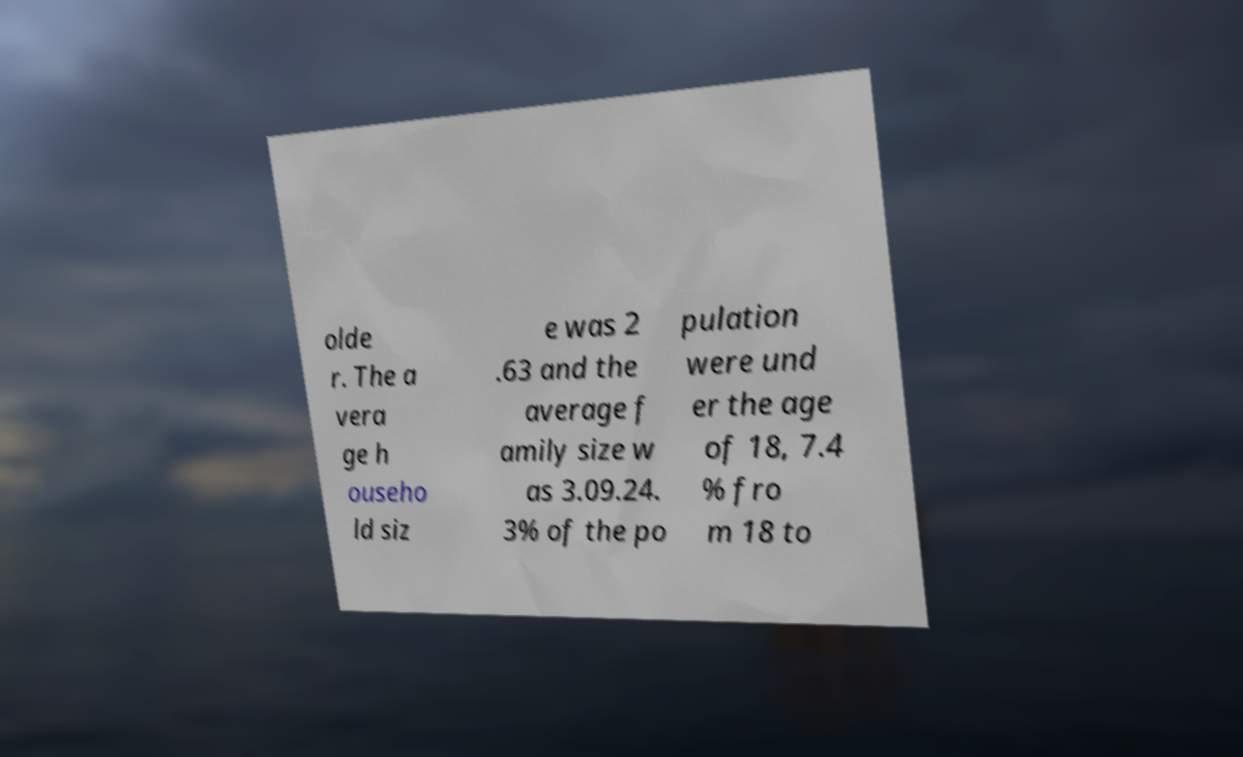Could you assist in decoding the text presented in this image and type it out clearly? olde r. The a vera ge h ouseho ld siz e was 2 .63 and the average f amily size w as 3.09.24. 3% of the po pulation were und er the age of 18, 7.4 % fro m 18 to 